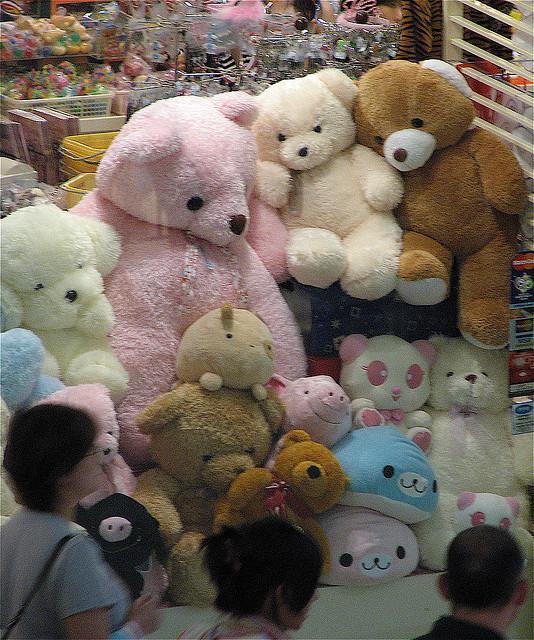How many teddy bears are visible?
Give a very brief answer. 14. How many people can you see?
Give a very brief answer. 3. 